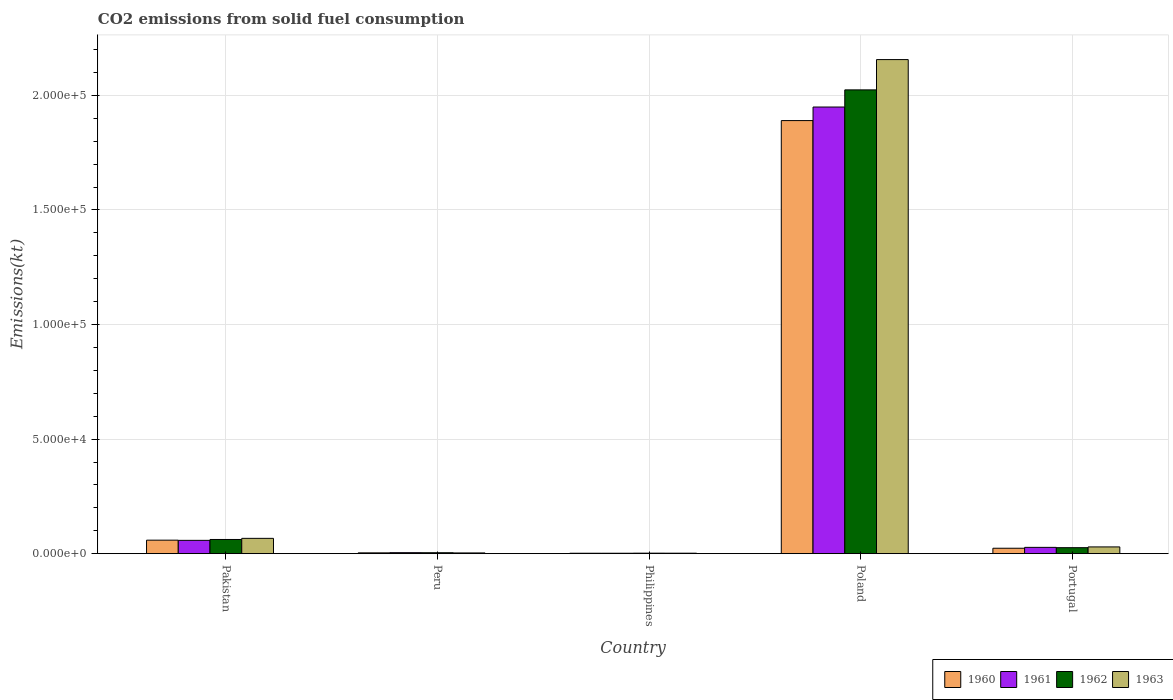How many different coloured bars are there?
Give a very brief answer. 4. Are the number of bars on each tick of the X-axis equal?
Keep it short and to the point. Yes. How many bars are there on the 1st tick from the left?
Provide a succinct answer. 4. How many bars are there on the 3rd tick from the right?
Ensure brevity in your answer.  4. What is the label of the 4th group of bars from the left?
Offer a terse response. Poland. In how many cases, is the number of bars for a given country not equal to the number of legend labels?
Your answer should be very brief. 0. What is the amount of CO2 emitted in 1962 in Pakistan?
Give a very brief answer. 6189.9. Across all countries, what is the maximum amount of CO2 emitted in 1962?
Offer a very short reply. 2.02e+05. Across all countries, what is the minimum amount of CO2 emitted in 1962?
Keep it short and to the point. 212.69. What is the total amount of CO2 emitted in 1963 in the graph?
Your response must be concise. 2.26e+05. What is the difference between the amount of CO2 emitted in 1962 in Philippines and that in Poland?
Provide a succinct answer. -2.02e+05. What is the difference between the amount of CO2 emitted in 1962 in Pakistan and the amount of CO2 emitted in 1963 in Portugal?
Provide a short and direct response. 3245.29. What is the average amount of CO2 emitted in 1962 per country?
Make the answer very short. 4.24e+04. What is the difference between the amount of CO2 emitted of/in 1962 and amount of CO2 emitted of/in 1960 in Philippines?
Offer a terse response. 33. In how many countries, is the amount of CO2 emitted in 1960 greater than 90000 kt?
Offer a very short reply. 1. What is the ratio of the amount of CO2 emitted in 1962 in Peru to that in Poland?
Offer a very short reply. 0. Is the amount of CO2 emitted in 1961 in Peru less than that in Philippines?
Your response must be concise. No. Is the difference between the amount of CO2 emitted in 1962 in Pakistan and Portugal greater than the difference between the amount of CO2 emitted in 1960 in Pakistan and Portugal?
Provide a succinct answer. Yes. What is the difference between the highest and the second highest amount of CO2 emitted in 1960?
Provide a short and direct response. 3527.65. What is the difference between the highest and the lowest amount of CO2 emitted in 1961?
Keep it short and to the point. 1.95e+05. In how many countries, is the amount of CO2 emitted in 1960 greater than the average amount of CO2 emitted in 1960 taken over all countries?
Give a very brief answer. 1. Is it the case that in every country, the sum of the amount of CO2 emitted in 1963 and amount of CO2 emitted in 1960 is greater than the sum of amount of CO2 emitted in 1962 and amount of CO2 emitted in 1961?
Keep it short and to the point. No. What does the 1st bar from the left in Peru represents?
Make the answer very short. 1960. What does the 1st bar from the right in Peru represents?
Make the answer very short. 1963. How many bars are there?
Give a very brief answer. 20. Are all the bars in the graph horizontal?
Provide a short and direct response. No. How many countries are there in the graph?
Make the answer very short. 5. What is the difference between two consecutive major ticks on the Y-axis?
Keep it short and to the point. 5.00e+04. Are the values on the major ticks of Y-axis written in scientific E-notation?
Provide a short and direct response. Yes. Does the graph contain any zero values?
Keep it short and to the point. No. Where does the legend appear in the graph?
Offer a very short reply. Bottom right. How many legend labels are there?
Offer a very short reply. 4. What is the title of the graph?
Your answer should be very brief. CO2 emissions from solid fuel consumption. What is the label or title of the X-axis?
Provide a short and direct response. Country. What is the label or title of the Y-axis?
Provide a succinct answer. Emissions(kt). What is the Emissions(kt) of 1960 in Pakistan?
Make the answer very short. 5892.87. What is the Emissions(kt) in 1961 in Pakistan?
Offer a very short reply. 5804.86. What is the Emissions(kt) in 1962 in Pakistan?
Make the answer very short. 6189.9. What is the Emissions(kt) in 1963 in Pakistan?
Provide a succinct answer. 6681.27. What is the Emissions(kt) in 1960 in Peru?
Your answer should be very brief. 352.03. What is the Emissions(kt) in 1961 in Peru?
Give a very brief answer. 432.71. What is the Emissions(kt) in 1962 in Peru?
Make the answer very short. 407.04. What is the Emissions(kt) in 1963 in Peru?
Offer a very short reply. 319.03. What is the Emissions(kt) in 1960 in Philippines?
Keep it short and to the point. 179.68. What is the Emissions(kt) in 1961 in Philippines?
Your answer should be compact. 179.68. What is the Emissions(kt) of 1962 in Philippines?
Your answer should be very brief. 212.69. What is the Emissions(kt) in 1963 in Philippines?
Provide a short and direct response. 201.69. What is the Emissions(kt) in 1960 in Poland?
Your answer should be compact. 1.89e+05. What is the Emissions(kt) in 1961 in Poland?
Ensure brevity in your answer.  1.95e+05. What is the Emissions(kt) of 1962 in Poland?
Provide a succinct answer. 2.02e+05. What is the Emissions(kt) of 1963 in Poland?
Keep it short and to the point. 2.16e+05. What is the Emissions(kt) in 1960 in Portugal?
Your response must be concise. 2365.22. What is the Emissions(kt) in 1961 in Portugal?
Make the answer very short. 2742.92. What is the Emissions(kt) of 1962 in Portugal?
Your answer should be compact. 2610.9. What is the Emissions(kt) in 1963 in Portugal?
Your response must be concise. 2944.6. Across all countries, what is the maximum Emissions(kt) of 1960?
Provide a succinct answer. 1.89e+05. Across all countries, what is the maximum Emissions(kt) of 1961?
Provide a succinct answer. 1.95e+05. Across all countries, what is the maximum Emissions(kt) of 1962?
Offer a terse response. 2.02e+05. Across all countries, what is the maximum Emissions(kt) in 1963?
Provide a succinct answer. 2.16e+05. Across all countries, what is the minimum Emissions(kt) in 1960?
Your response must be concise. 179.68. Across all countries, what is the minimum Emissions(kt) of 1961?
Provide a succinct answer. 179.68. Across all countries, what is the minimum Emissions(kt) in 1962?
Your answer should be very brief. 212.69. Across all countries, what is the minimum Emissions(kt) of 1963?
Your response must be concise. 201.69. What is the total Emissions(kt) in 1960 in the graph?
Keep it short and to the point. 1.98e+05. What is the total Emissions(kt) in 1961 in the graph?
Make the answer very short. 2.04e+05. What is the total Emissions(kt) in 1962 in the graph?
Make the answer very short. 2.12e+05. What is the total Emissions(kt) in 1963 in the graph?
Give a very brief answer. 2.26e+05. What is the difference between the Emissions(kt) in 1960 in Pakistan and that in Peru?
Ensure brevity in your answer.  5540.84. What is the difference between the Emissions(kt) in 1961 in Pakistan and that in Peru?
Make the answer very short. 5372.15. What is the difference between the Emissions(kt) of 1962 in Pakistan and that in Peru?
Your answer should be compact. 5782.86. What is the difference between the Emissions(kt) in 1963 in Pakistan and that in Peru?
Your response must be concise. 6362.24. What is the difference between the Emissions(kt) of 1960 in Pakistan and that in Philippines?
Keep it short and to the point. 5713.19. What is the difference between the Emissions(kt) in 1961 in Pakistan and that in Philippines?
Give a very brief answer. 5625.18. What is the difference between the Emissions(kt) in 1962 in Pakistan and that in Philippines?
Provide a short and direct response. 5977.21. What is the difference between the Emissions(kt) of 1963 in Pakistan and that in Philippines?
Your answer should be compact. 6479.59. What is the difference between the Emissions(kt) of 1960 in Pakistan and that in Poland?
Provide a succinct answer. -1.83e+05. What is the difference between the Emissions(kt) in 1961 in Pakistan and that in Poland?
Keep it short and to the point. -1.89e+05. What is the difference between the Emissions(kt) of 1962 in Pakistan and that in Poland?
Your response must be concise. -1.96e+05. What is the difference between the Emissions(kt) of 1963 in Pakistan and that in Poland?
Keep it short and to the point. -2.09e+05. What is the difference between the Emissions(kt) of 1960 in Pakistan and that in Portugal?
Your response must be concise. 3527.65. What is the difference between the Emissions(kt) in 1961 in Pakistan and that in Portugal?
Offer a very short reply. 3061.95. What is the difference between the Emissions(kt) of 1962 in Pakistan and that in Portugal?
Offer a terse response. 3578.99. What is the difference between the Emissions(kt) in 1963 in Pakistan and that in Portugal?
Your answer should be very brief. 3736.67. What is the difference between the Emissions(kt) in 1960 in Peru and that in Philippines?
Provide a succinct answer. 172.35. What is the difference between the Emissions(kt) in 1961 in Peru and that in Philippines?
Ensure brevity in your answer.  253.02. What is the difference between the Emissions(kt) in 1962 in Peru and that in Philippines?
Give a very brief answer. 194.35. What is the difference between the Emissions(kt) of 1963 in Peru and that in Philippines?
Your response must be concise. 117.34. What is the difference between the Emissions(kt) of 1960 in Peru and that in Poland?
Offer a terse response. -1.89e+05. What is the difference between the Emissions(kt) in 1961 in Peru and that in Poland?
Make the answer very short. -1.95e+05. What is the difference between the Emissions(kt) of 1962 in Peru and that in Poland?
Your response must be concise. -2.02e+05. What is the difference between the Emissions(kt) in 1963 in Peru and that in Poland?
Offer a terse response. -2.15e+05. What is the difference between the Emissions(kt) in 1960 in Peru and that in Portugal?
Make the answer very short. -2013.18. What is the difference between the Emissions(kt) of 1961 in Peru and that in Portugal?
Give a very brief answer. -2310.21. What is the difference between the Emissions(kt) of 1962 in Peru and that in Portugal?
Give a very brief answer. -2203.87. What is the difference between the Emissions(kt) of 1963 in Peru and that in Portugal?
Ensure brevity in your answer.  -2625.57. What is the difference between the Emissions(kt) in 1960 in Philippines and that in Poland?
Provide a succinct answer. -1.89e+05. What is the difference between the Emissions(kt) of 1961 in Philippines and that in Poland?
Keep it short and to the point. -1.95e+05. What is the difference between the Emissions(kt) of 1962 in Philippines and that in Poland?
Make the answer very short. -2.02e+05. What is the difference between the Emissions(kt) in 1963 in Philippines and that in Poland?
Ensure brevity in your answer.  -2.15e+05. What is the difference between the Emissions(kt) of 1960 in Philippines and that in Portugal?
Your answer should be very brief. -2185.53. What is the difference between the Emissions(kt) of 1961 in Philippines and that in Portugal?
Your answer should be compact. -2563.23. What is the difference between the Emissions(kt) in 1962 in Philippines and that in Portugal?
Ensure brevity in your answer.  -2398.22. What is the difference between the Emissions(kt) of 1963 in Philippines and that in Portugal?
Provide a succinct answer. -2742.92. What is the difference between the Emissions(kt) in 1960 in Poland and that in Portugal?
Offer a terse response. 1.87e+05. What is the difference between the Emissions(kt) in 1961 in Poland and that in Portugal?
Ensure brevity in your answer.  1.92e+05. What is the difference between the Emissions(kt) of 1962 in Poland and that in Portugal?
Give a very brief answer. 2.00e+05. What is the difference between the Emissions(kt) of 1963 in Poland and that in Portugal?
Your answer should be very brief. 2.13e+05. What is the difference between the Emissions(kt) in 1960 in Pakistan and the Emissions(kt) in 1961 in Peru?
Keep it short and to the point. 5460.16. What is the difference between the Emissions(kt) in 1960 in Pakistan and the Emissions(kt) in 1962 in Peru?
Your response must be concise. 5485.83. What is the difference between the Emissions(kt) of 1960 in Pakistan and the Emissions(kt) of 1963 in Peru?
Your response must be concise. 5573.84. What is the difference between the Emissions(kt) of 1961 in Pakistan and the Emissions(kt) of 1962 in Peru?
Your answer should be compact. 5397.82. What is the difference between the Emissions(kt) of 1961 in Pakistan and the Emissions(kt) of 1963 in Peru?
Make the answer very short. 5485.83. What is the difference between the Emissions(kt) in 1962 in Pakistan and the Emissions(kt) in 1963 in Peru?
Give a very brief answer. 5870.87. What is the difference between the Emissions(kt) in 1960 in Pakistan and the Emissions(kt) in 1961 in Philippines?
Your response must be concise. 5713.19. What is the difference between the Emissions(kt) of 1960 in Pakistan and the Emissions(kt) of 1962 in Philippines?
Provide a succinct answer. 5680.18. What is the difference between the Emissions(kt) of 1960 in Pakistan and the Emissions(kt) of 1963 in Philippines?
Keep it short and to the point. 5691.18. What is the difference between the Emissions(kt) of 1961 in Pakistan and the Emissions(kt) of 1962 in Philippines?
Ensure brevity in your answer.  5592.18. What is the difference between the Emissions(kt) of 1961 in Pakistan and the Emissions(kt) of 1963 in Philippines?
Offer a terse response. 5603.18. What is the difference between the Emissions(kt) in 1962 in Pakistan and the Emissions(kt) in 1963 in Philippines?
Your answer should be compact. 5988.21. What is the difference between the Emissions(kt) of 1960 in Pakistan and the Emissions(kt) of 1961 in Poland?
Offer a terse response. -1.89e+05. What is the difference between the Emissions(kt) of 1960 in Pakistan and the Emissions(kt) of 1962 in Poland?
Provide a succinct answer. -1.97e+05. What is the difference between the Emissions(kt) in 1960 in Pakistan and the Emissions(kt) in 1963 in Poland?
Ensure brevity in your answer.  -2.10e+05. What is the difference between the Emissions(kt) of 1961 in Pakistan and the Emissions(kt) of 1962 in Poland?
Keep it short and to the point. -1.97e+05. What is the difference between the Emissions(kt) of 1961 in Pakistan and the Emissions(kt) of 1963 in Poland?
Ensure brevity in your answer.  -2.10e+05. What is the difference between the Emissions(kt) of 1962 in Pakistan and the Emissions(kt) of 1963 in Poland?
Your answer should be compact. -2.09e+05. What is the difference between the Emissions(kt) in 1960 in Pakistan and the Emissions(kt) in 1961 in Portugal?
Ensure brevity in your answer.  3149.95. What is the difference between the Emissions(kt) of 1960 in Pakistan and the Emissions(kt) of 1962 in Portugal?
Your response must be concise. 3281.97. What is the difference between the Emissions(kt) of 1960 in Pakistan and the Emissions(kt) of 1963 in Portugal?
Give a very brief answer. 2948.27. What is the difference between the Emissions(kt) in 1961 in Pakistan and the Emissions(kt) in 1962 in Portugal?
Make the answer very short. 3193.96. What is the difference between the Emissions(kt) in 1961 in Pakistan and the Emissions(kt) in 1963 in Portugal?
Offer a very short reply. 2860.26. What is the difference between the Emissions(kt) in 1962 in Pakistan and the Emissions(kt) in 1963 in Portugal?
Provide a succinct answer. 3245.3. What is the difference between the Emissions(kt) of 1960 in Peru and the Emissions(kt) of 1961 in Philippines?
Your answer should be very brief. 172.35. What is the difference between the Emissions(kt) of 1960 in Peru and the Emissions(kt) of 1962 in Philippines?
Your answer should be very brief. 139.35. What is the difference between the Emissions(kt) of 1960 in Peru and the Emissions(kt) of 1963 in Philippines?
Offer a terse response. 150.35. What is the difference between the Emissions(kt) of 1961 in Peru and the Emissions(kt) of 1962 in Philippines?
Ensure brevity in your answer.  220.02. What is the difference between the Emissions(kt) in 1961 in Peru and the Emissions(kt) in 1963 in Philippines?
Ensure brevity in your answer.  231.02. What is the difference between the Emissions(kt) of 1962 in Peru and the Emissions(kt) of 1963 in Philippines?
Keep it short and to the point. 205.35. What is the difference between the Emissions(kt) of 1960 in Peru and the Emissions(kt) of 1961 in Poland?
Your answer should be very brief. -1.95e+05. What is the difference between the Emissions(kt) in 1960 in Peru and the Emissions(kt) in 1962 in Poland?
Offer a terse response. -2.02e+05. What is the difference between the Emissions(kt) of 1960 in Peru and the Emissions(kt) of 1963 in Poland?
Provide a succinct answer. -2.15e+05. What is the difference between the Emissions(kt) of 1961 in Peru and the Emissions(kt) of 1962 in Poland?
Offer a very short reply. -2.02e+05. What is the difference between the Emissions(kt) in 1961 in Peru and the Emissions(kt) in 1963 in Poland?
Give a very brief answer. -2.15e+05. What is the difference between the Emissions(kt) in 1962 in Peru and the Emissions(kt) in 1963 in Poland?
Offer a very short reply. -2.15e+05. What is the difference between the Emissions(kt) in 1960 in Peru and the Emissions(kt) in 1961 in Portugal?
Keep it short and to the point. -2390.88. What is the difference between the Emissions(kt) of 1960 in Peru and the Emissions(kt) of 1962 in Portugal?
Your response must be concise. -2258.87. What is the difference between the Emissions(kt) of 1960 in Peru and the Emissions(kt) of 1963 in Portugal?
Make the answer very short. -2592.57. What is the difference between the Emissions(kt) of 1961 in Peru and the Emissions(kt) of 1962 in Portugal?
Give a very brief answer. -2178.2. What is the difference between the Emissions(kt) of 1961 in Peru and the Emissions(kt) of 1963 in Portugal?
Give a very brief answer. -2511.89. What is the difference between the Emissions(kt) in 1962 in Peru and the Emissions(kt) in 1963 in Portugal?
Keep it short and to the point. -2537.56. What is the difference between the Emissions(kt) of 1960 in Philippines and the Emissions(kt) of 1961 in Poland?
Offer a very short reply. -1.95e+05. What is the difference between the Emissions(kt) in 1960 in Philippines and the Emissions(kt) in 1962 in Poland?
Ensure brevity in your answer.  -2.02e+05. What is the difference between the Emissions(kt) of 1960 in Philippines and the Emissions(kt) of 1963 in Poland?
Ensure brevity in your answer.  -2.15e+05. What is the difference between the Emissions(kt) in 1961 in Philippines and the Emissions(kt) in 1962 in Poland?
Provide a succinct answer. -2.02e+05. What is the difference between the Emissions(kt) in 1961 in Philippines and the Emissions(kt) in 1963 in Poland?
Offer a very short reply. -2.15e+05. What is the difference between the Emissions(kt) in 1962 in Philippines and the Emissions(kt) in 1963 in Poland?
Keep it short and to the point. -2.15e+05. What is the difference between the Emissions(kt) in 1960 in Philippines and the Emissions(kt) in 1961 in Portugal?
Your answer should be compact. -2563.23. What is the difference between the Emissions(kt) in 1960 in Philippines and the Emissions(kt) in 1962 in Portugal?
Offer a very short reply. -2431.22. What is the difference between the Emissions(kt) in 1960 in Philippines and the Emissions(kt) in 1963 in Portugal?
Your answer should be very brief. -2764.92. What is the difference between the Emissions(kt) of 1961 in Philippines and the Emissions(kt) of 1962 in Portugal?
Your response must be concise. -2431.22. What is the difference between the Emissions(kt) in 1961 in Philippines and the Emissions(kt) in 1963 in Portugal?
Provide a short and direct response. -2764.92. What is the difference between the Emissions(kt) of 1962 in Philippines and the Emissions(kt) of 1963 in Portugal?
Provide a succinct answer. -2731.91. What is the difference between the Emissions(kt) in 1960 in Poland and the Emissions(kt) in 1961 in Portugal?
Make the answer very short. 1.86e+05. What is the difference between the Emissions(kt) in 1960 in Poland and the Emissions(kt) in 1962 in Portugal?
Offer a very short reply. 1.86e+05. What is the difference between the Emissions(kt) in 1960 in Poland and the Emissions(kt) in 1963 in Portugal?
Provide a short and direct response. 1.86e+05. What is the difference between the Emissions(kt) of 1961 in Poland and the Emissions(kt) of 1962 in Portugal?
Your answer should be very brief. 1.92e+05. What is the difference between the Emissions(kt) of 1961 in Poland and the Emissions(kt) of 1963 in Portugal?
Provide a succinct answer. 1.92e+05. What is the difference between the Emissions(kt) in 1962 in Poland and the Emissions(kt) in 1963 in Portugal?
Offer a terse response. 1.99e+05. What is the average Emissions(kt) in 1960 per country?
Your response must be concise. 3.96e+04. What is the average Emissions(kt) in 1961 per country?
Your answer should be very brief. 4.08e+04. What is the average Emissions(kt) in 1962 per country?
Offer a terse response. 4.24e+04. What is the average Emissions(kt) of 1963 per country?
Offer a terse response. 4.52e+04. What is the difference between the Emissions(kt) of 1960 and Emissions(kt) of 1961 in Pakistan?
Offer a terse response. 88.01. What is the difference between the Emissions(kt) in 1960 and Emissions(kt) in 1962 in Pakistan?
Your answer should be very brief. -297.03. What is the difference between the Emissions(kt) in 1960 and Emissions(kt) in 1963 in Pakistan?
Ensure brevity in your answer.  -788.4. What is the difference between the Emissions(kt) in 1961 and Emissions(kt) in 1962 in Pakistan?
Provide a succinct answer. -385.04. What is the difference between the Emissions(kt) of 1961 and Emissions(kt) of 1963 in Pakistan?
Your answer should be very brief. -876.41. What is the difference between the Emissions(kt) in 1962 and Emissions(kt) in 1963 in Pakistan?
Provide a succinct answer. -491.38. What is the difference between the Emissions(kt) in 1960 and Emissions(kt) in 1961 in Peru?
Give a very brief answer. -80.67. What is the difference between the Emissions(kt) of 1960 and Emissions(kt) of 1962 in Peru?
Your answer should be very brief. -55.01. What is the difference between the Emissions(kt) of 1960 and Emissions(kt) of 1963 in Peru?
Your response must be concise. 33. What is the difference between the Emissions(kt) of 1961 and Emissions(kt) of 1962 in Peru?
Offer a terse response. 25.67. What is the difference between the Emissions(kt) of 1961 and Emissions(kt) of 1963 in Peru?
Provide a succinct answer. 113.68. What is the difference between the Emissions(kt) in 1962 and Emissions(kt) in 1963 in Peru?
Keep it short and to the point. 88.01. What is the difference between the Emissions(kt) in 1960 and Emissions(kt) in 1961 in Philippines?
Offer a terse response. 0. What is the difference between the Emissions(kt) in 1960 and Emissions(kt) in 1962 in Philippines?
Offer a terse response. -33. What is the difference between the Emissions(kt) in 1960 and Emissions(kt) in 1963 in Philippines?
Ensure brevity in your answer.  -22. What is the difference between the Emissions(kt) in 1961 and Emissions(kt) in 1962 in Philippines?
Offer a terse response. -33. What is the difference between the Emissions(kt) of 1961 and Emissions(kt) of 1963 in Philippines?
Keep it short and to the point. -22. What is the difference between the Emissions(kt) in 1962 and Emissions(kt) in 1963 in Philippines?
Your response must be concise. 11. What is the difference between the Emissions(kt) of 1960 and Emissions(kt) of 1961 in Poland?
Offer a terse response. -5918.54. What is the difference between the Emissions(kt) of 1960 and Emissions(kt) of 1962 in Poland?
Offer a terse response. -1.34e+04. What is the difference between the Emissions(kt) of 1960 and Emissions(kt) of 1963 in Poland?
Ensure brevity in your answer.  -2.66e+04. What is the difference between the Emissions(kt) of 1961 and Emissions(kt) of 1962 in Poland?
Your response must be concise. -7484.35. What is the difference between the Emissions(kt) in 1961 and Emissions(kt) in 1963 in Poland?
Make the answer very short. -2.07e+04. What is the difference between the Emissions(kt) of 1962 and Emissions(kt) of 1963 in Poland?
Make the answer very short. -1.32e+04. What is the difference between the Emissions(kt) in 1960 and Emissions(kt) in 1961 in Portugal?
Your response must be concise. -377.7. What is the difference between the Emissions(kt) in 1960 and Emissions(kt) in 1962 in Portugal?
Keep it short and to the point. -245.69. What is the difference between the Emissions(kt) of 1960 and Emissions(kt) of 1963 in Portugal?
Make the answer very short. -579.39. What is the difference between the Emissions(kt) in 1961 and Emissions(kt) in 1962 in Portugal?
Your answer should be very brief. 132.01. What is the difference between the Emissions(kt) of 1961 and Emissions(kt) of 1963 in Portugal?
Offer a very short reply. -201.69. What is the difference between the Emissions(kt) in 1962 and Emissions(kt) in 1963 in Portugal?
Your answer should be very brief. -333.7. What is the ratio of the Emissions(kt) of 1960 in Pakistan to that in Peru?
Offer a terse response. 16.74. What is the ratio of the Emissions(kt) in 1961 in Pakistan to that in Peru?
Provide a short and direct response. 13.42. What is the ratio of the Emissions(kt) of 1962 in Pakistan to that in Peru?
Your answer should be compact. 15.21. What is the ratio of the Emissions(kt) of 1963 in Pakistan to that in Peru?
Provide a succinct answer. 20.94. What is the ratio of the Emissions(kt) of 1960 in Pakistan to that in Philippines?
Ensure brevity in your answer.  32.8. What is the ratio of the Emissions(kt) in 1961 in Pakistan to that in Philippines?
Keep it short and to the point. 32.31. What is the ratio of the Emissions(kt) of 1962 in Pakistan to that in Philippines?
Make the answer very short. 29.1. What is the ratio of the Emissions(kt) of 1963 in Pakistan to that in Philippines?
Offer a very short reply. 33.13. What is the ratio of the Emissions(kt) of 1960 in Pakistan to that in Poland?
Provide a short and direct response. 0.03. What is the ratio of the Emissions(kt) of 1961 in Pakistan to that in Poland?
Your answer should be compact. 0.03. What is the ratio of the Emissions(kt) of 1962 in Pakistan to that in Poland?
Make the answer very short. 0.03. What is the ratio of the Emissions(kt) in 1963 in Pakistan to that in Poland?
Offer a terse response. 0.03. What is the ratio of the Emissions(kt) of 1960 in Pakistan to that in Portugal?
Provide a succinct answer. 2.49. What is the ratio of the Emissions(kt) of 1961 in Pakistan to that in Portugal?
Give a very brief answer. 2.12. What is the ratio of the Emissions(kt) in 1962 in Pakistan to that in Portugal?
Offer a terse response. 2.37. What is the ratio of the Emissions(kt) in 1963 in Pakistan to that in Portugal?
Make the answer very short. 2.27. What is the ratio of the Emissions(kt) in 1960 in Peru to that in Philippines?
Ensure brevity in your answer.  1.96. What is the ratio of the Emissions(kt) of 1961 in Peru to that in Philippines?
Your response must be concise. 2.41. What is the ratio of the Emissions(kt) of 1962 in Peru to that in Philippines?
Provide a short and direct response. 1.91. What is the ratio of the Emissions(kt) of 1963 in Peru to that in Philippines?
Make the answer very short. 1.58. What is the ratio of the Emissions(kt) in 1960 in Peru to that in Poland?
Offer a very short reply. 0. What is the ratio of the Emissions(kt) of 1961 in Peru to that in Poland?
Keep it short and to the point. 0. What is the ratio of the Emissions(kt) of 1962 in Peru to that in Poland?
Provide a short and direct response. 0. What is the ratio of the Emissions(kt) of 1963 in Peru to that in Poland?
Make the answer very short. 0. What is the ratio of the Emissions(kt) in 1960 in Peru to that in Portugal?
Ensure brevity in your answer.  0.15. What is the ratio of the Emissions(kt) in 1961 in Peru to that in Portugal?
Your response must be concise. 0.16. What is the ratio of the Emissions(kt) in 1962 in Peru to that in Portugal?
Offer a very short reply. 0.16. What is the ratio of the Emissions(kt) in 1963 in Peru to that in Portugal?
Keep it short and to the point. 0.11. What is the ratio of the Emissions(kt) in 1960 in Philippines to that in Poland?
Your answer should be very brief. 0. What is the ratio of the Emissions(kt) of 1961 in Philippines to that in Poland?
Provide a short and direct response. 0. What is the ratio of the Emissions(kt) of 1962 in Philippines to that in Poland?
Provide a short and direct response. 0. What is the ratio of the Emissions(kt) of 1963 in Philippines to that in Poland?
Make the answer very short. 0. What is the ratio of the Emissions(kt) of 1960 in Philippines to that in Portugal?
Your response must be concise. 0.08. What is the ratio of the Emissions(kt) of 1961 in Philippines to that in Portugal?
Provide a succinct answer. 0.07. What is the ratio of the Emissions(kt) of 1962 in Philippines to that in Portugal?
Your response must be concise. 0.08. What is the ratio of the Emissions(kt) in 1963 in Philippines to that in Portugal?
Offer a terse response. 0.07. What is the ratio of the Emissions(kt) in 1960 in Poland to that in Portugal?
Give a very brief answer. 79.92. What is the ratio of the Emissions(kt) of 1961 in Poland to that in Portugal?
Give a very brief answer. 71.07. What is the ratio of the Emissions(kt) of 1962 in Poland to that in Portugal?
Ensure brevity in your answer.  77.53. What is the ratio of the Emissions(kt) in 1963 in Poland to that in Portugal?
Ensure brevity in your answer.  73.24. What is the difference between the highest and the second highest Emissions(kt) in 1960?
Your answer should be very brief. 1.83e+05. What is the difference between the highest and the second highest Emissions(kt) in 1961?
Offer a terse response. 1.89e+05. What is the difference between the highest and the second highest Emissions(kt) of 1962?
Ensure brevity in your answer.  1.96e+05. What is the difference between the highest and the second highest Emissions(kt) of 1963?
Offer a terse response. 2.09e+05. What is the difference between the highest and the lowest Emissions(kt) of 1960?
Ensure brevity in your answer.  1.89e+05. What is the difference between the highest and the lowest Emissions(kt) in 1961?
Ensure brevity in your answer.  1.95e+05. What is the difference between the highest and the lowest Emissions(kt) of 1962?
Your answer should be very brief. 2.02e+05. What is the difference between the highest and the lowest Emissions(kt) in 1963?
Provide a short and direct response. 2.15e+05. 